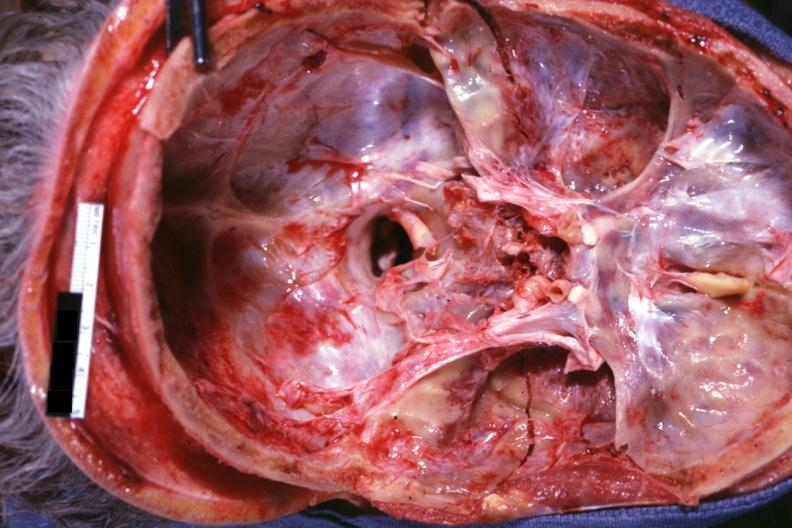s basilar skull fracture present?
Answer the question using a single word or phrase. Yes 